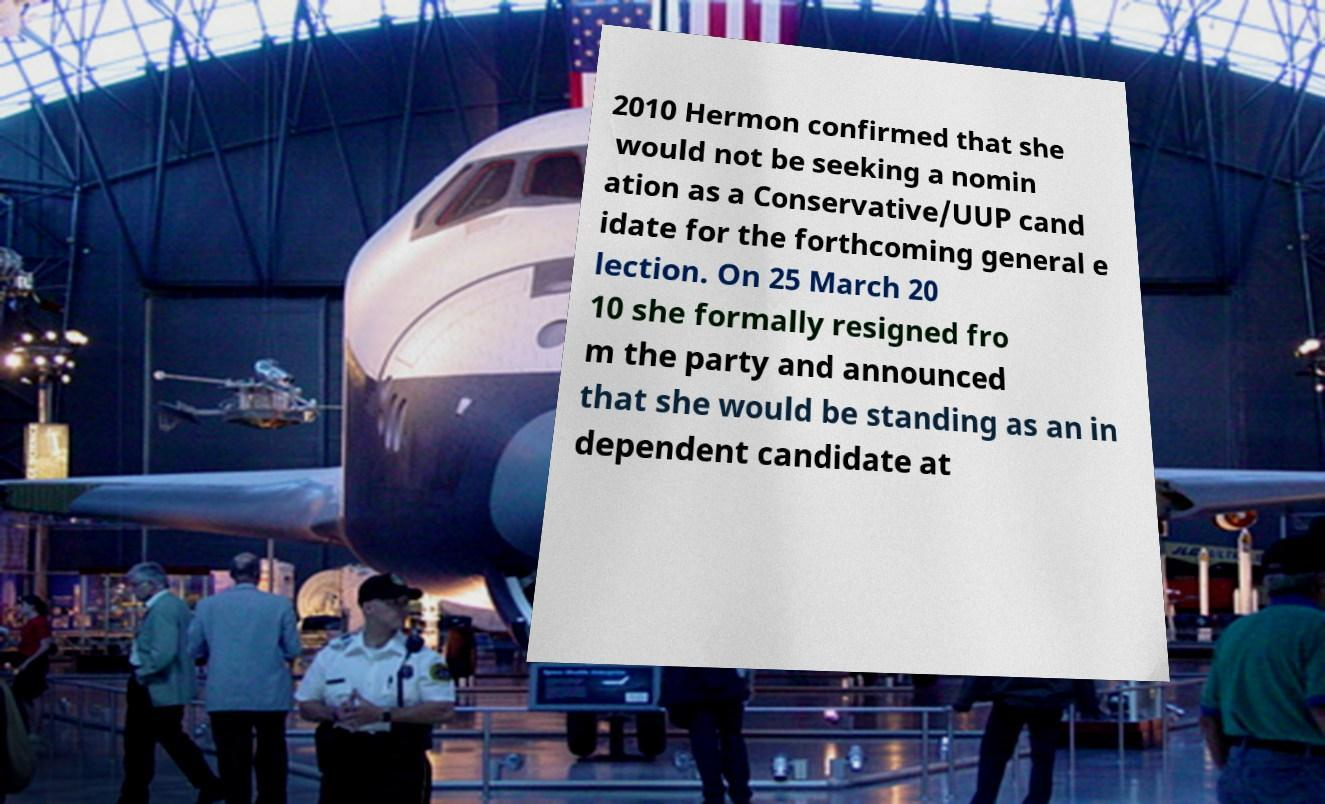I need the written content from this picture converted into text. Can you do that? 2010 Hermon confirmed that she would not be seeking a nomin ation as a Conservative/UUP cand idate for the forthcoming general e lection. On 25 March 20 10 she formally resigned fro m the party and announced that she would be standing as an in dependent candidate at 